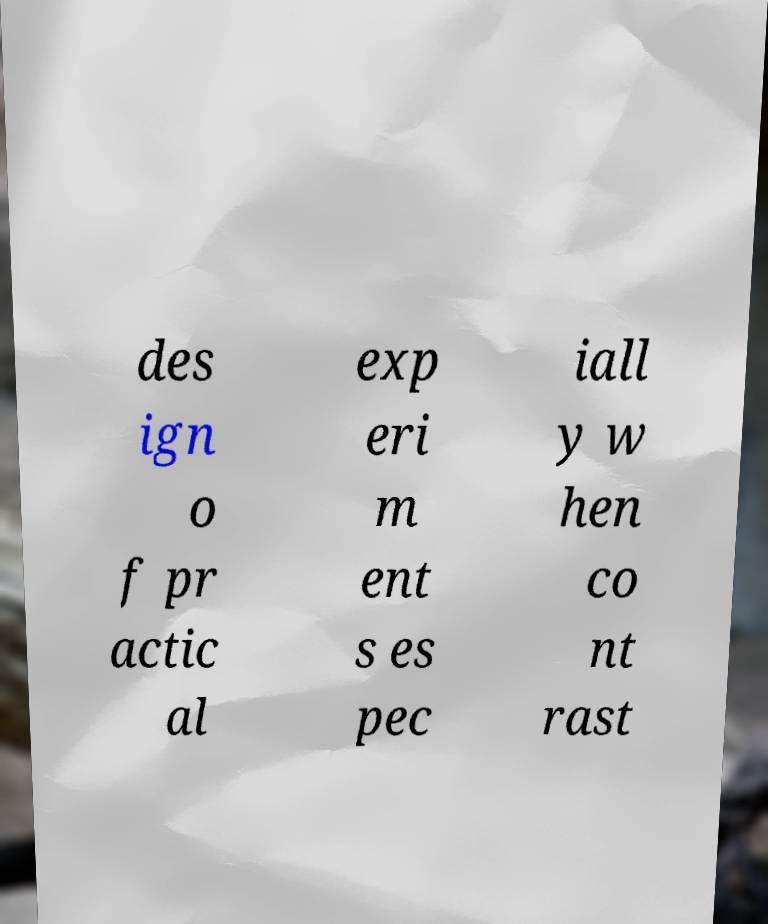Could you assist in decoding the text presented in this image and type it out clearly? des ign o f pr actic al exp eri m ent s es pec iall y w hen co nt rast 